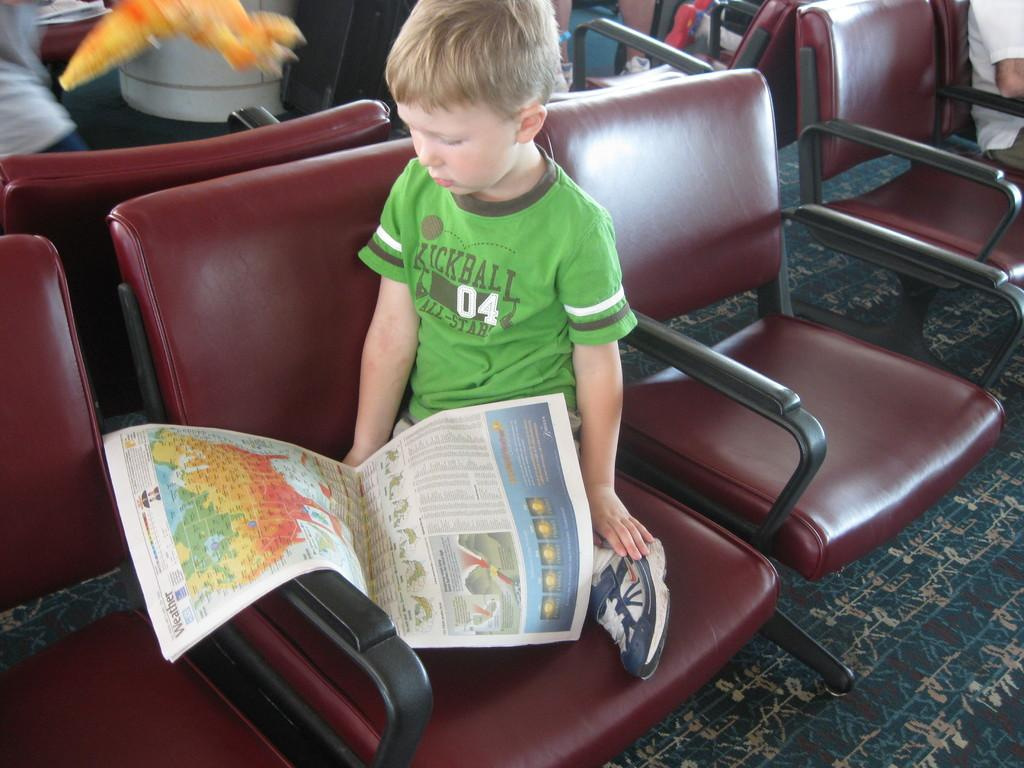What is the main subject of the image? The main subject of the image is a kid. What is the kid doing in the image? The kid is sitting in a chair and looking at a newspaper. Are there any other people in the image? Yes, there are people sitting behind the kid. Reasoning: Let' Let's think step by step in order to produce the conversation. We start by identifying the main subject of the image, which is the kid. Then, we describe what the kid is doing, which is sitting in a chair and looking at a newspaper. Finally, we mention the presence of other people in the image, who are sitting behind the kid. Absurd Question/Answer: What type of trousers is the kid wearing in the image? The provided facts do not mention the type of trousers the kid is wearing, so we cannot answer this question definitively. What idea did the kid come up with while looking at the newspaper? The provided facts do not mention any ideas or thoughts the kid might have had while looking at the newspaper, so we cannot answer this question definitively. What type of plane can be seen flying in the background of the image? There is no plane visible in the image; it only features a kid sitting in a chair and looking at a newspaper, along with people sitting behind the kid. 